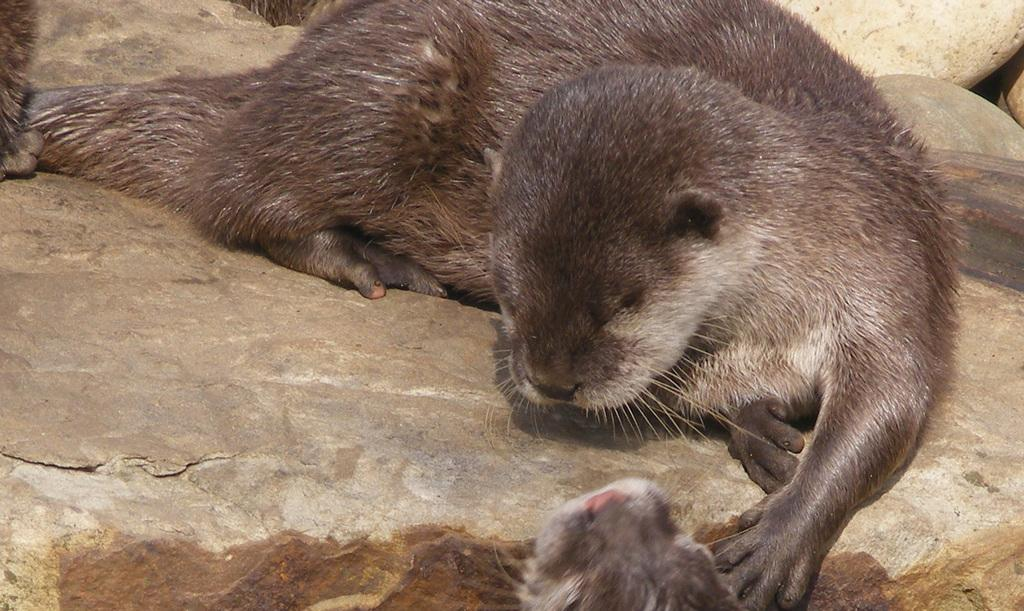What type of living organisms are present in the image? There are animals in the image. What color are the animals? The animals are pale brown in color. Where are the animals located in the image? The animals are on stones. What type of food is the cook preparing for the animals in the image? There is no cook or food preparation present in the image; it only features animals on stones. 